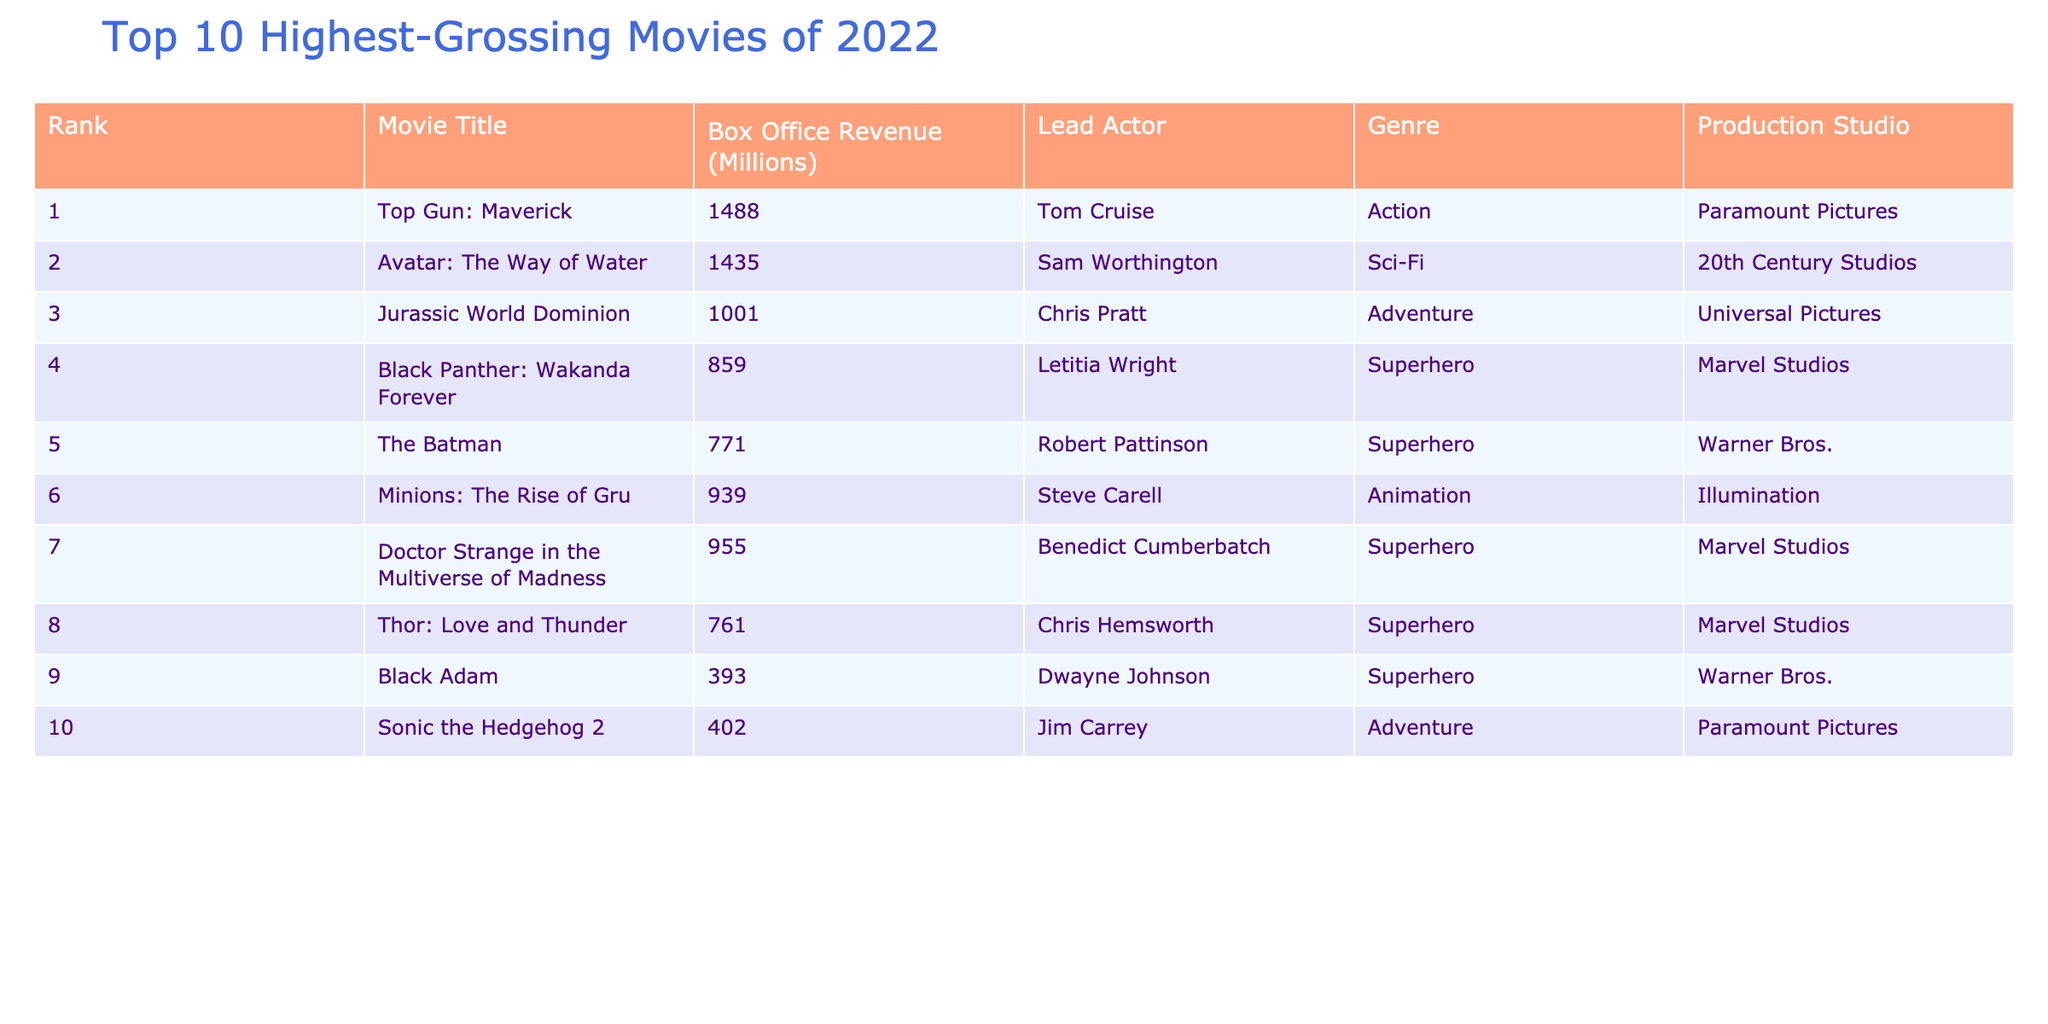What is the highest-grossing movie of 2022? According to the table, the movie with the highest box office revenue is "Top Gun: Maverick," which grossed 1488 million.
Answer: Top Gun: Maverick Which movie earned just over 900 million at the box office? By examining the table, "Minions: The Rise of Gru" has a box office revenue of 939 million, which is just over 900 million.
Answer: Minions: The Rise of Gru How many superhero movies are in the top 10 list? Since the table lists four movies with the genre labeled as 'Superhero' (Black Panther: Wakanda Forever, The Batman, Doctor Strange in the Multiverse of Madness, Thor: Love and Thunder, and Black Adam), we can conclude there are five superhero movies.
Answer: Five What is the total box office revenue for the top 3 movies combined? We need to add the box office revenues of the top 3 movies: 1488 + 1435 + 1001 = 3924 million, so the total revenue for the top 3 movies is 3924 million.
Answer: 3924 million Is the box office revenue of "Sonic the Hedgehog 2" more than 500 million? The table indicates "Sonic the Hedgehog 2" has a revenue of 402 million, which is less than 500 million.
Answer: No Which production studio produced the movie "Jurassic World Dominion"? The table shows that "Jurassic World Dominion" was produced by Universal Pictures.
Answer: Universal Pictures What is the average box office revenue of the top 10 movies? We add all the revenues (sum = 1488 + 1435 + 1001 + 859 + 771 + 939 + 955 + 761 + 393 + 402 =  6101 million) and then divide by the number of movies (10). Thus, the average revenue is 6101/10 = 610.1 million.
Answer: 610.1 million Which two movies had revenues closest to each other, and what were those revenues? Looking through the box office revenues, "Black Adam" (393 million) and "Sonic the Hedgehog 2" (402 million) are the closest; their difference is 9 million.
Answer: Black Adam and Sonic the Hedgehog 2; 393 million and 402 million Who is the lead actor in "Black Panther: Wakanda Forever"? According to the table, Letitia Wright is listed as the lead actor for "Black Panther: Wakanda Forever."
Answer: Letitia Wright What percentage of the total box office does "The Batman" contribute? First, we find the total box office revenue (6101 million) and the revenue for "The Batman" (771 million). Then, we calculate (771/6101) * 100 = 12.65%. Therefore, "The Batman" contributes about 12.65% to the total.
Answer: 12.65% 